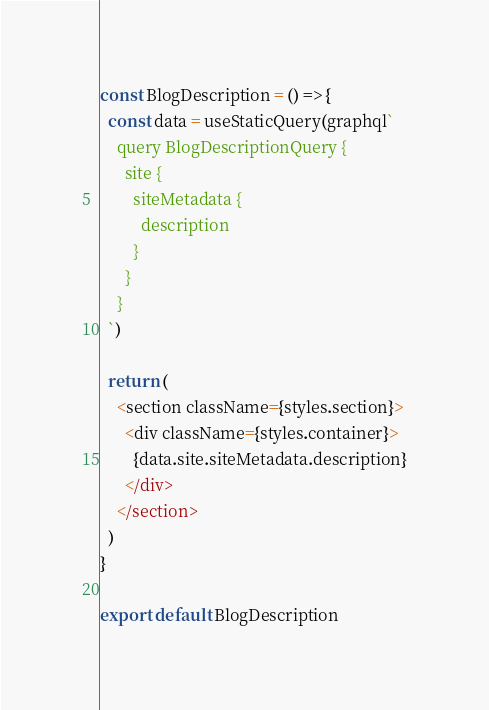Convert code to text. <code><loc_0><loc_0><loc_500><loc_500><_JavaScript_>
const BlogDescription = () => {
  const data = useStaticQuery(graphql`
    query BlogDescriptionQuery {
      site {
        siteMetadata {
          description
        }
      }
    }
  `)

  return (
    <section className={styles.section}>
      <div className={styles.container}>
        {data.site.siteMetadata.description}
      </div>
    </section>
  )
}

export default BlogDescription
</code> 